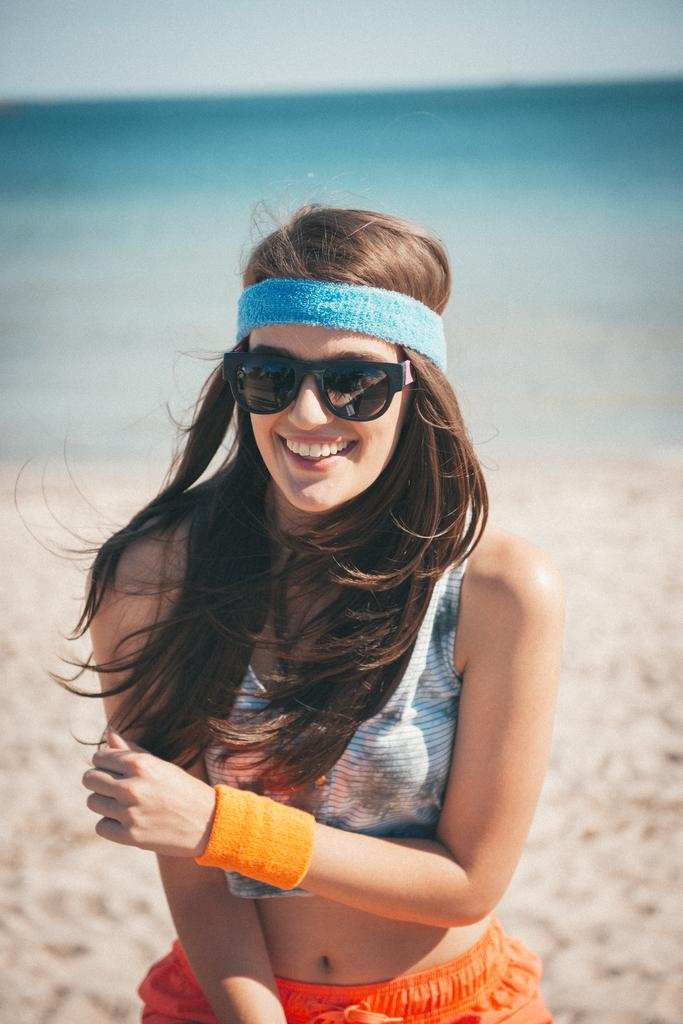Who is present in the image? There is a woman in the image. What is the woman wearing? The woman is wearing clothes, spectacles, a hand band, and a hair band. What is the woman's facial expression? The woman is smiling. What type of environment is visible in the image? There is sand, water, and sky visible in the image. How is the background of the image depicted? The background of the image is blurred. What type of suit is the woman wearing in the image? The woman is not wearing a suit in the image; she is wearing clothes, spectacles, a hand band, and a hair band. What show is the woman performing in the image? There is no show or performance depicted in the image; it simply shows a woman smiling in a natural environment. 